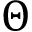Convert formula to latex. <formula><loc_0><loc_0><loc_500><loc_500>\Theta</formula> 